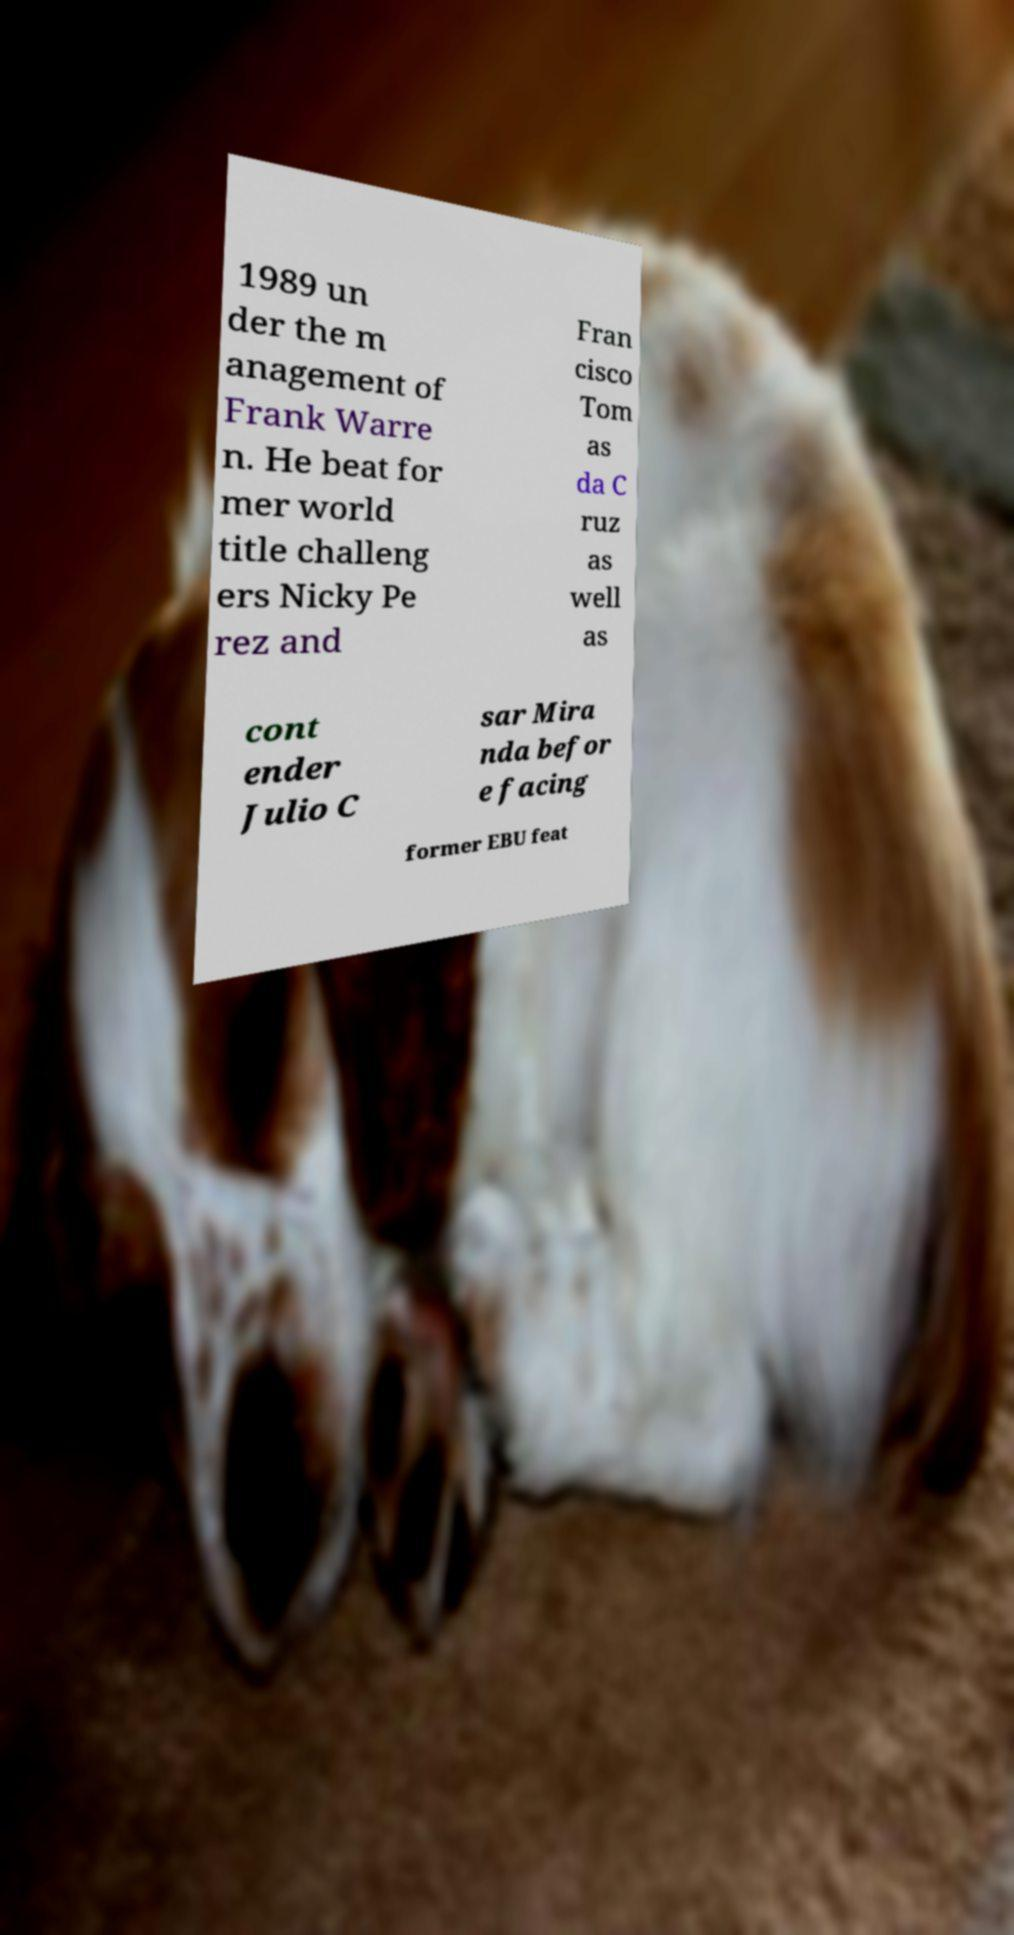What messages or text are displayed in this image? I need them in a readable, typed format. 1989 un der the m anagement of Frank Warre n. He beat for mer world title challeng ers Nicky Pe rez and Fran cisco Tom as da C ruz as well as cont ender Julio C sar Mira nda befor e facing former EBU feat 